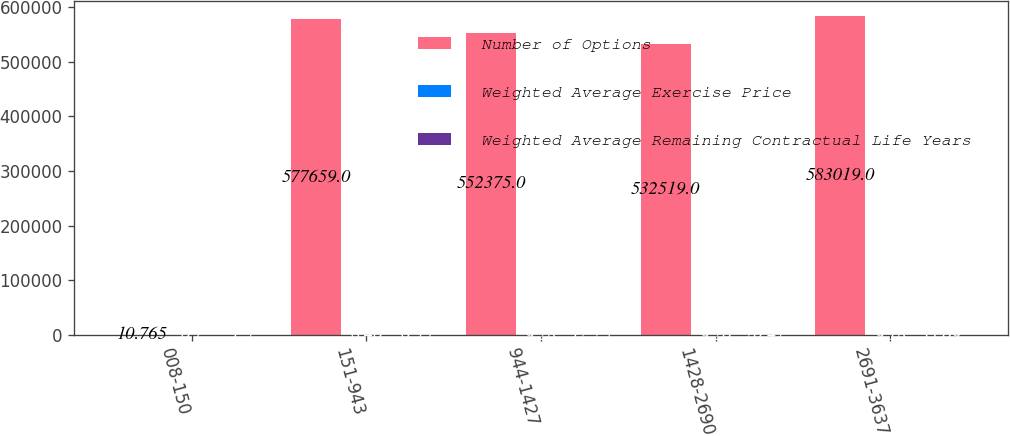Convert chart to OTSL. <chart><loc_0><loc_0><loc_500><loc_500><stacked_bar_chart><ecel><fcel>008-150<fcel>151-943<fcel>944-1427<fcel>1428-2690<fcel>2691-3637<nl><fcel>Number of Options<fcel>10.765<fcel>577659<fcel>552375<fcel>532519<fcel>583019<nl><fcel>Weighted Average Exercise Price<fcel>6.7<fcel>8.46<fcel>9.28<fcel>9.26<fcel>9.18<nl><fcel>Weighted Average Remaining Contractual Life Years<fcel>1.5<fcel>6.35<fcel>12.25<fcel>20.47<fcel>33.09<nl></chart> 